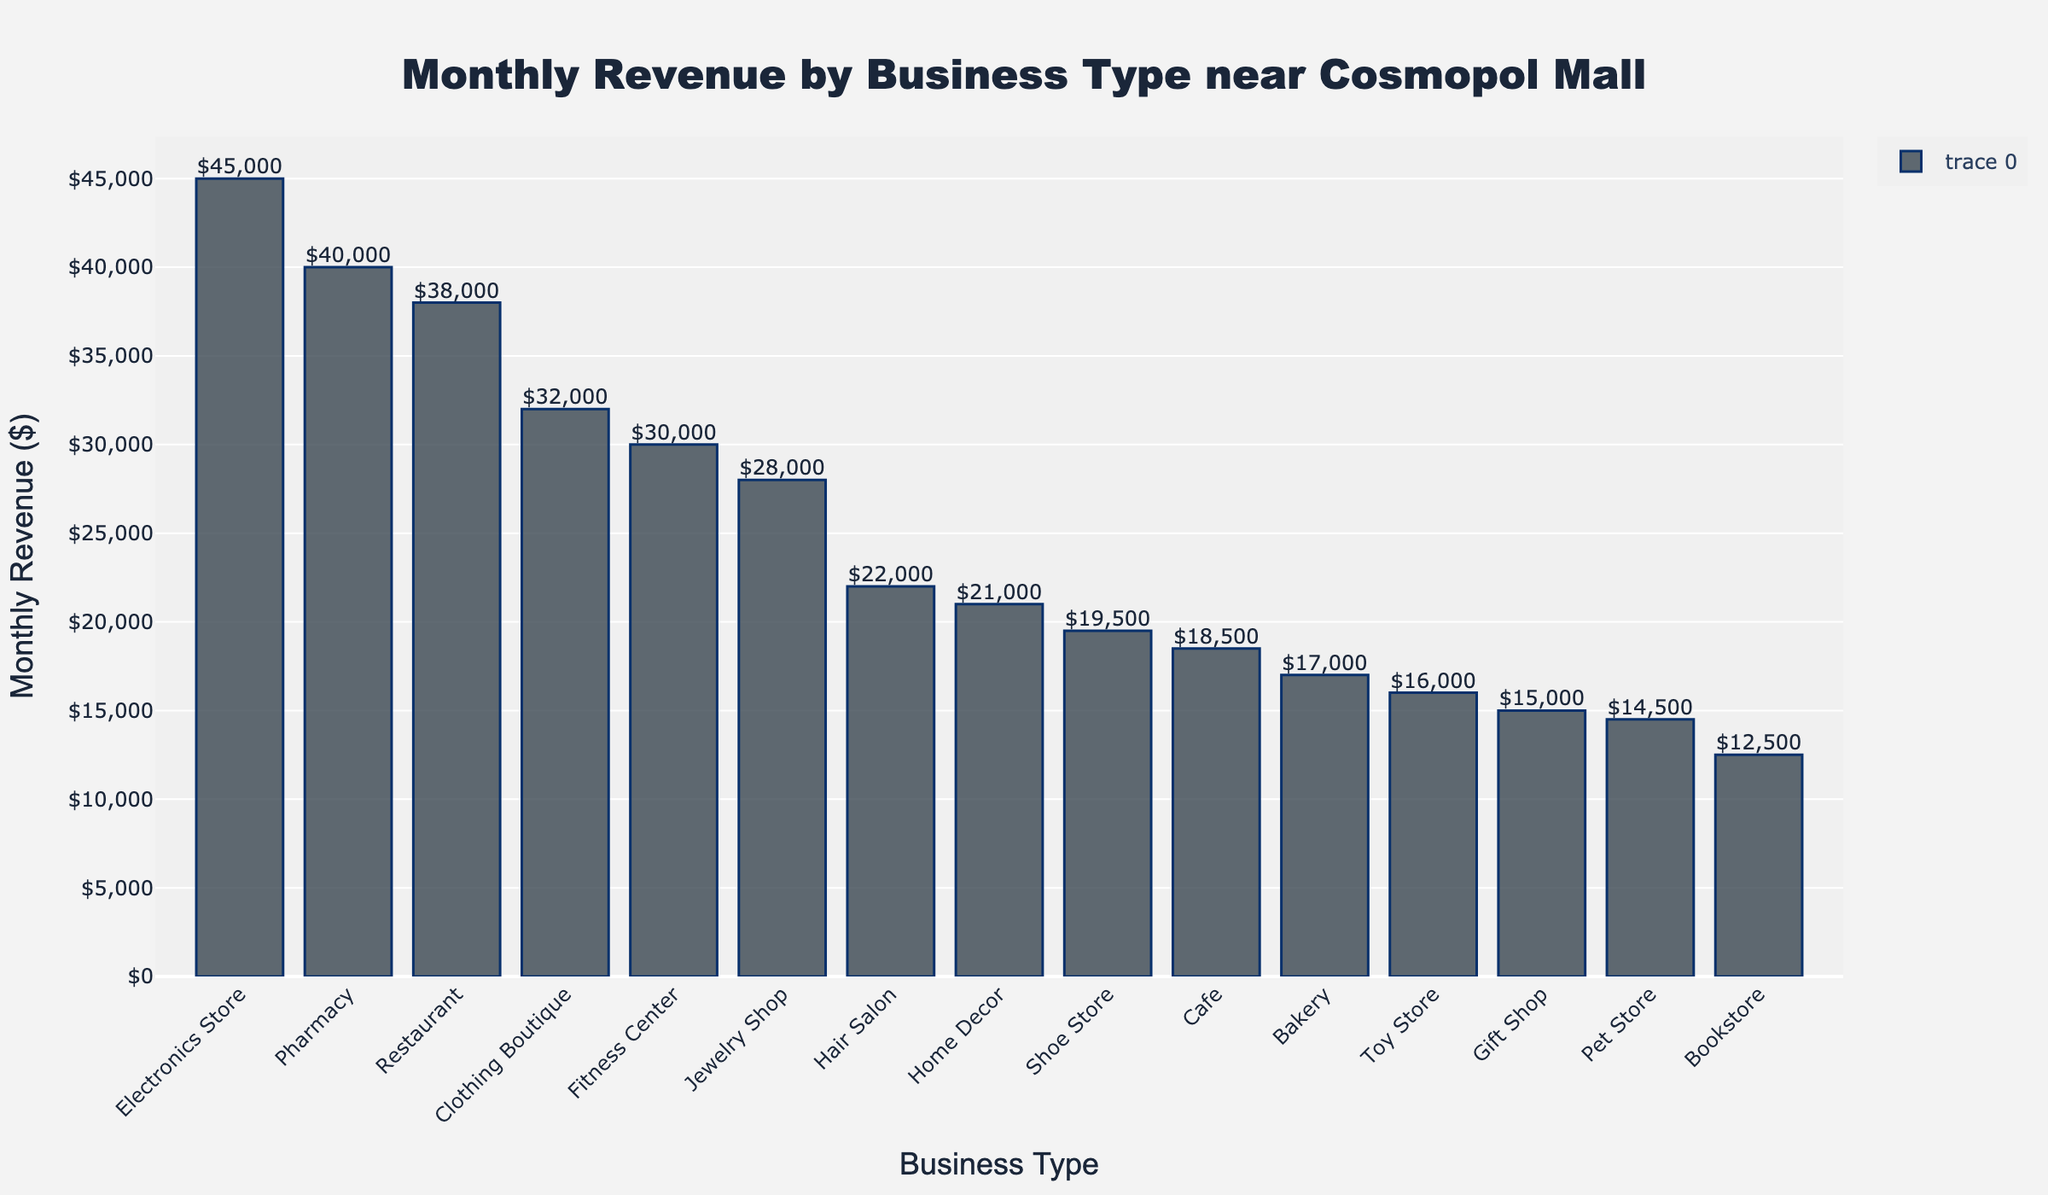What is the business type with the highest monthly revenue? The bar chart shows the revenue for each business type near Cosmopol Mall. By observing the tallest bar, we can determine that the Electronics Store has the highest monthly revenue.
Answer: Electronics Store Which two business types have the closest monthly revenues? By comparing the heights of the bars, we can see that the Bakery and the Toy Store have very similar heights, indicating similar monthly revenues.
Answer: Bakery and Toy Store What is the total monthly revenue for the Cafe, Bookstore, and Gift Shop combined? To find the total monthly revenue for these three business types, we sum their individual revenues: Café ($18,500) + Bookstore ($12,500) + Gift Shop ($15,000) = $46,000.
Answer: $46,000 How much more revenue does the Restaurant make compared to the Shoe Store? By locating the two bars and subtracting the Shoe Store's revenue from the Restaurant's revenue: Restaurant ($38,000) - Shoe Store ($19,500) = $18,500.
Answer: $18,500 What is the average monthly revenue of all business types? First, we sum all the revenues of the business types, then divide by the number of business types: (18,500 + 32,000 + 45,000 + 12,500 + 22,000 + 28,000 + 19,500 + 38,000 + 15,000 + 30,000 + 17,000 + 40,000 + 14,500 + 16,000 + 21,000) / 15 = $24,500.
Answer: $24,500 By how much does the revenue of the Pharmacy exceed the average monthly revenue of all businesses? First, calculate the average monthly revenue, which is $24,500. Then, subtract this average from the Pharmacy's revenue: Pharmacy ($40,000) - Average ($24,500) = $15,500.
Answer: $15,500 Which business type has the lowest monthly revenue and what is that amount? By looking at the shortest bar on the chart, we can identify the Bookstore as the business type with the lowest monthly revenue at $12,500.
Answer: Bookstore, $12,500 Is the Clothing Boutique's revenue more or less than double the revenue of the Pet Store? By how much? First, calculate double the Pet Store's revenue: 2 x $14,500 = $29,000. The Clothing Boutique's revenue is $32,000, which is $3,000 more than double the Pet Store's revenue.
Answer: More, $3,000 